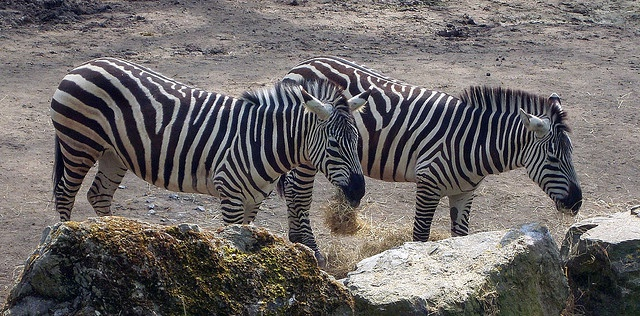Describe the objects in this image and their specific colors. I can see zebra in black, gray, darkgray, and lightgray tones and zebra in black, gray, darkgray, and lightgray tones in this image. 